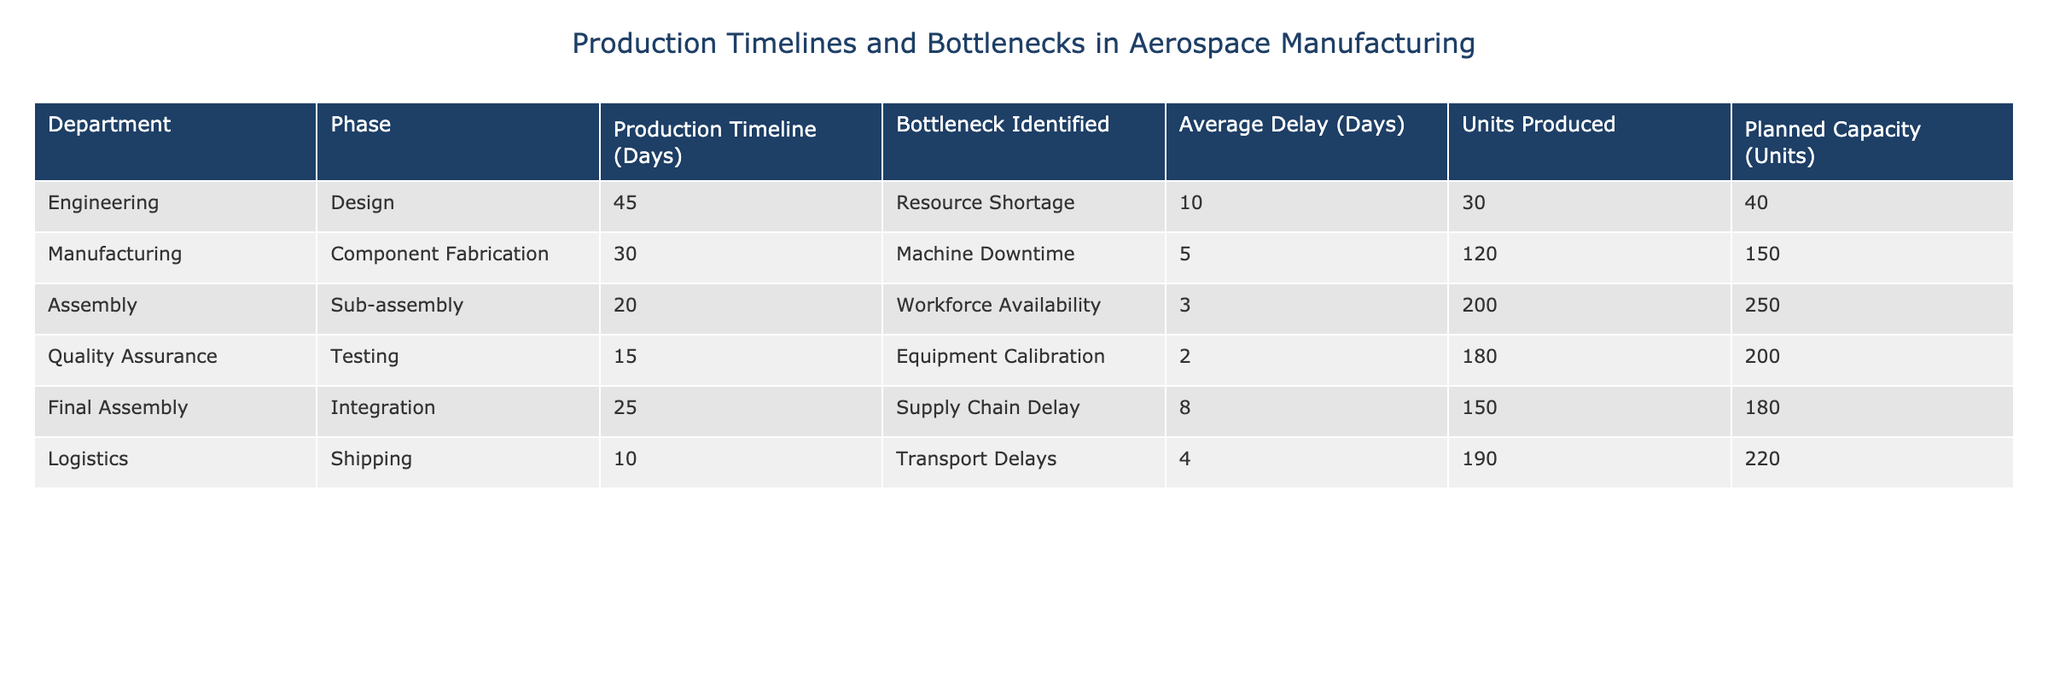What is the average production timeline across all departments? To find the average production timeline, sum the production timelines for each department: 45 + 30 + 20 + 15 + 25 + 10 = 145 days. Then, divide by the number of departments (6): 145 / 6 = 24.17.
Answer: 24.17 days Which department experienced the longest average delay? The average delays from each department are: Engineering 10, Manufacturing 5, Assembly 3, Quality Assurance 2, Final Assembly 8, Logistics 4. The highest value is 10 days from Engineering.
Answer: Engineering Is the number of units produced in the Assembly phase greater than the planned capacity? The units produced in Assembly are 200, and the planned capacity is 250, so 200 < 250. Thus, it is false that the number of units produced is greater than planned capacity.
Answer: No What is the total number of units produced across all departments? To find the total, sum the units produced from each department: 30 + 120 + 200 + 180 + 150 + 190 = 1,070 units.
Answer: 1,070 units Which department had a bottleneck due to machine downtime? From the table, the department with the bottleneck identified as machine downtime is Manufacturing.
Answer: Manufacturing What is the difference between planned capacity and units produced in the Engineering department? The planned capacity for Engineering is 40 units, and the units produced are 30. The difference is calculated as 40 - 30 = 10 units.
Answer: 10 units What is the highest average delay among all phases combined? The average delays for each phase are as follows: Engineering 10, Manufacturing 5, Assembly 3, Quality Assurance 2, Final Assembly 8, Logistics 4. The highest average delay is 10 days from Engineering.
Answer: 10 days In which department is the bottleneck not related to resources or workforce? The bottlenecks related to resources or workforce are from Engineering, Assembly, and Logistics. The remaining bottleneck is from Quality Assurance, which is identified as equipment calibration.
Answer: Quality Assurance How many departments have production timelines greater than 25 days? The departments with production timelines greater than 25 days are Engineering (45), Manufacturing (30), and Final Assembly (25), totaling 3 departments.
Answer: 3 departments 